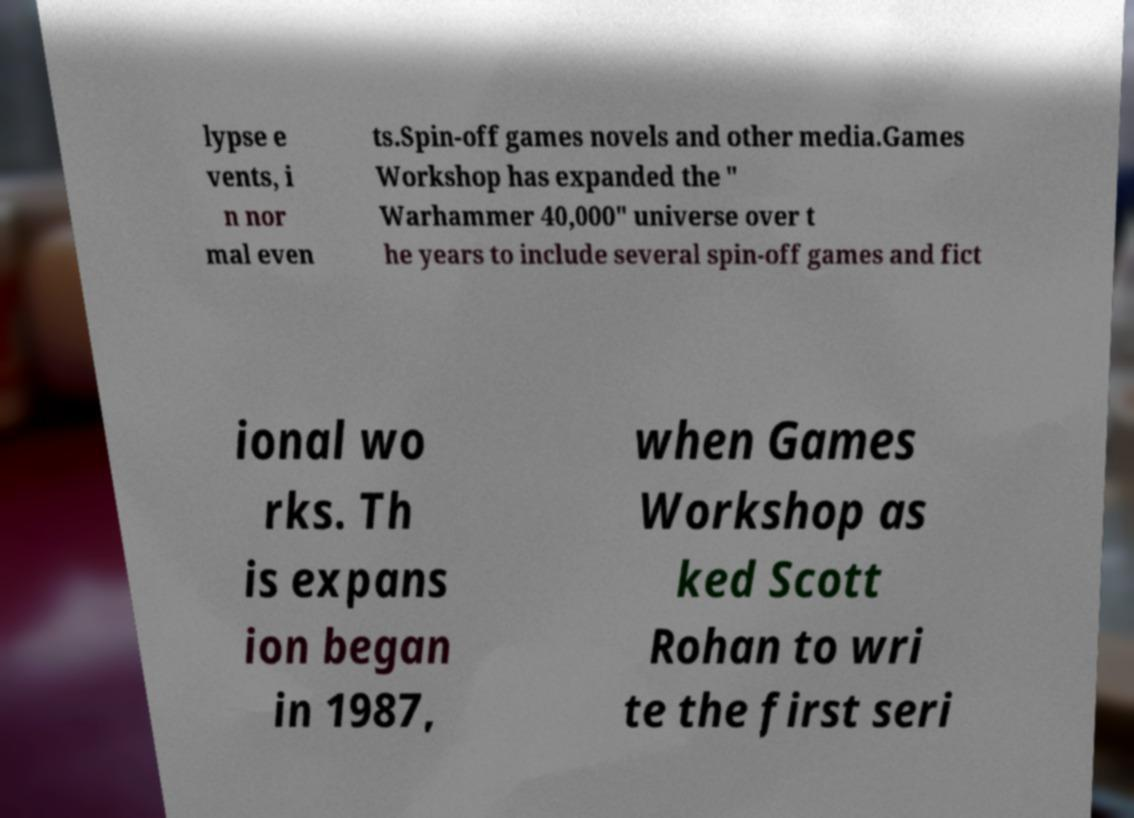Please read and relay the text visible in this image. What does it say? lypse e vents, i n nor mal even ts.Spin-off games novels and other media.Games Workshop has expanded the " Warhammer 40,000" universe over t he years to include several spin-off games and fict ional wo rks. Th is expans ion began in 1987, when Games Workshop as ked Scott Rohan to wri te the first seri 